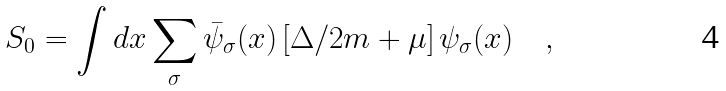<formula> <loc_0><loc_0><loc_500><loc_500>S _ { 0 } = \int d x \sum _ { \sigma } \bar { \psi } _ { \sigma } ( x ) \left [ \Delta / 2 m + \mu \right ] \psi _ { \sigma } ( x ) \quad ,</formula> 